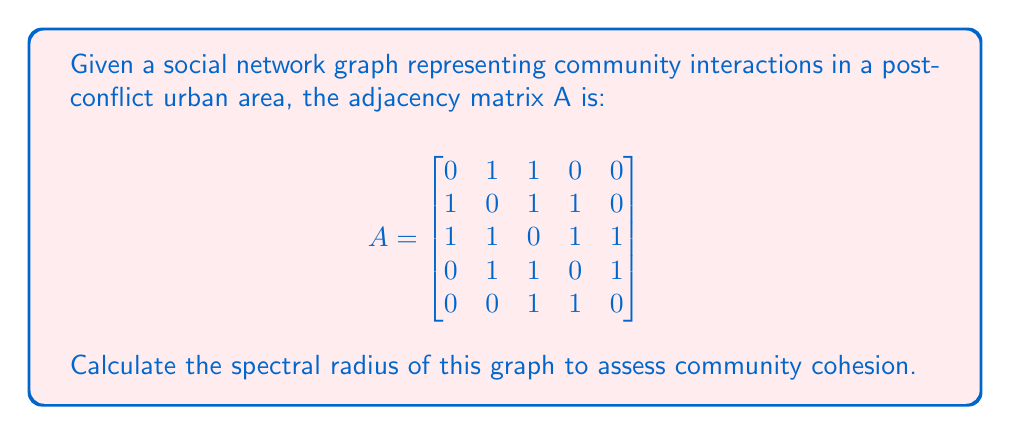Teach me how to tackle this problem. To determine the spectral radius of the social network graph, we need to follow these steps:

1) The spectral radius is the largest absolute eigenvalue of the adjacency matrix A.

2) To find the eigenvalues, we need to solve the characteristic equation:
   
   $$det(A - \lambda I) = 0$$

   where $I$ is the 5x5 identity matrix and $\lambda$ represents the eigenvalues.

3) Expanding this determinant gives us the characteristic polynomial:

   $$\lambda^5 - 7\lambda^3 - 4\lambda^2 + 3\lambda + 1 = 0$$

4) This polynomial is difficult to solve analytically. In practice, we would use numerical methods to approximate the roots.

5) Using a numerical solver, we find that the roots (eigenvalues) are approximately:
   
   $\lambda_1 \approx 2.4815$
   $\lambda_2 \approx -1.7321$
   $\lambda_3 \approx 0.8794$
   $\lambda_4 \approx -0.5288$
   $\lambda_5 \approx 0$

6) The spectral radius is the largest absolute value among these eigenvalues, which is $|\lambda_1| \approx 2.4815$.

7) In the context of social network analysis, a larger spectral radius indicates higher connectivity and potentially stronger community cohesion. This value suggests a moderately connected community, which could be interpreted as a sign of ongoing recovery and rebuilding of social ties in the post-conflict urban area.
Answer: 2.4815 